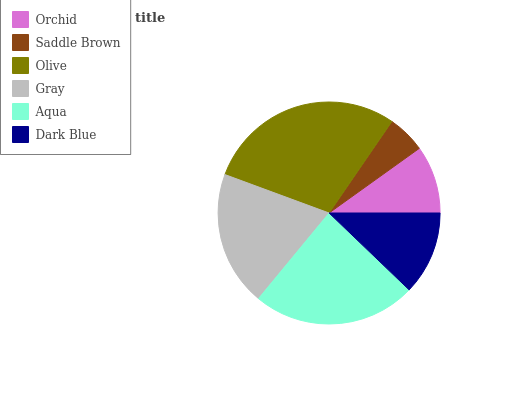Is Saddle Brown the minimum?
Answer yes or no. Yes. Is Olive the maximum?
Answer yes or no. Yes. Is Olive the minimum?
Answer yes or no. No. Is Saddle Brown the maximum?
Answer yes or no. No. Is Olive greater than Saddle Brown?
Answer yes or no. Yes. Is Saddle Brown less than Olive?
Answer yes or no. Yes. Is Saddle Brown greater than Olive?
Answer yes or no. No. Is Olive less than Saddle Brown?
Answer yes or no. No. Is Gray the high median?
Answer yes or no. Yes. Is Dark Blue the low median?
Answer yes or no. Yes. Is Olive the high median?
Answer yes or no. No. Is Orchid the low median?
Answer yes or no. No. 